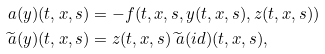<formula> <loc_0><loc_0><loc_500><loc_500>\ a ( y ) ( t , x , s ) & = - f ( t , x , s , y ( t , x , s ) , z ( t , x , s ) ) \\ \widetilde { \ a } ( y ) ( t , x , s ) & = z ( t , x , s ) \widetilde { \ a } ( i d ) ( t , x , s ) ,</formula> 